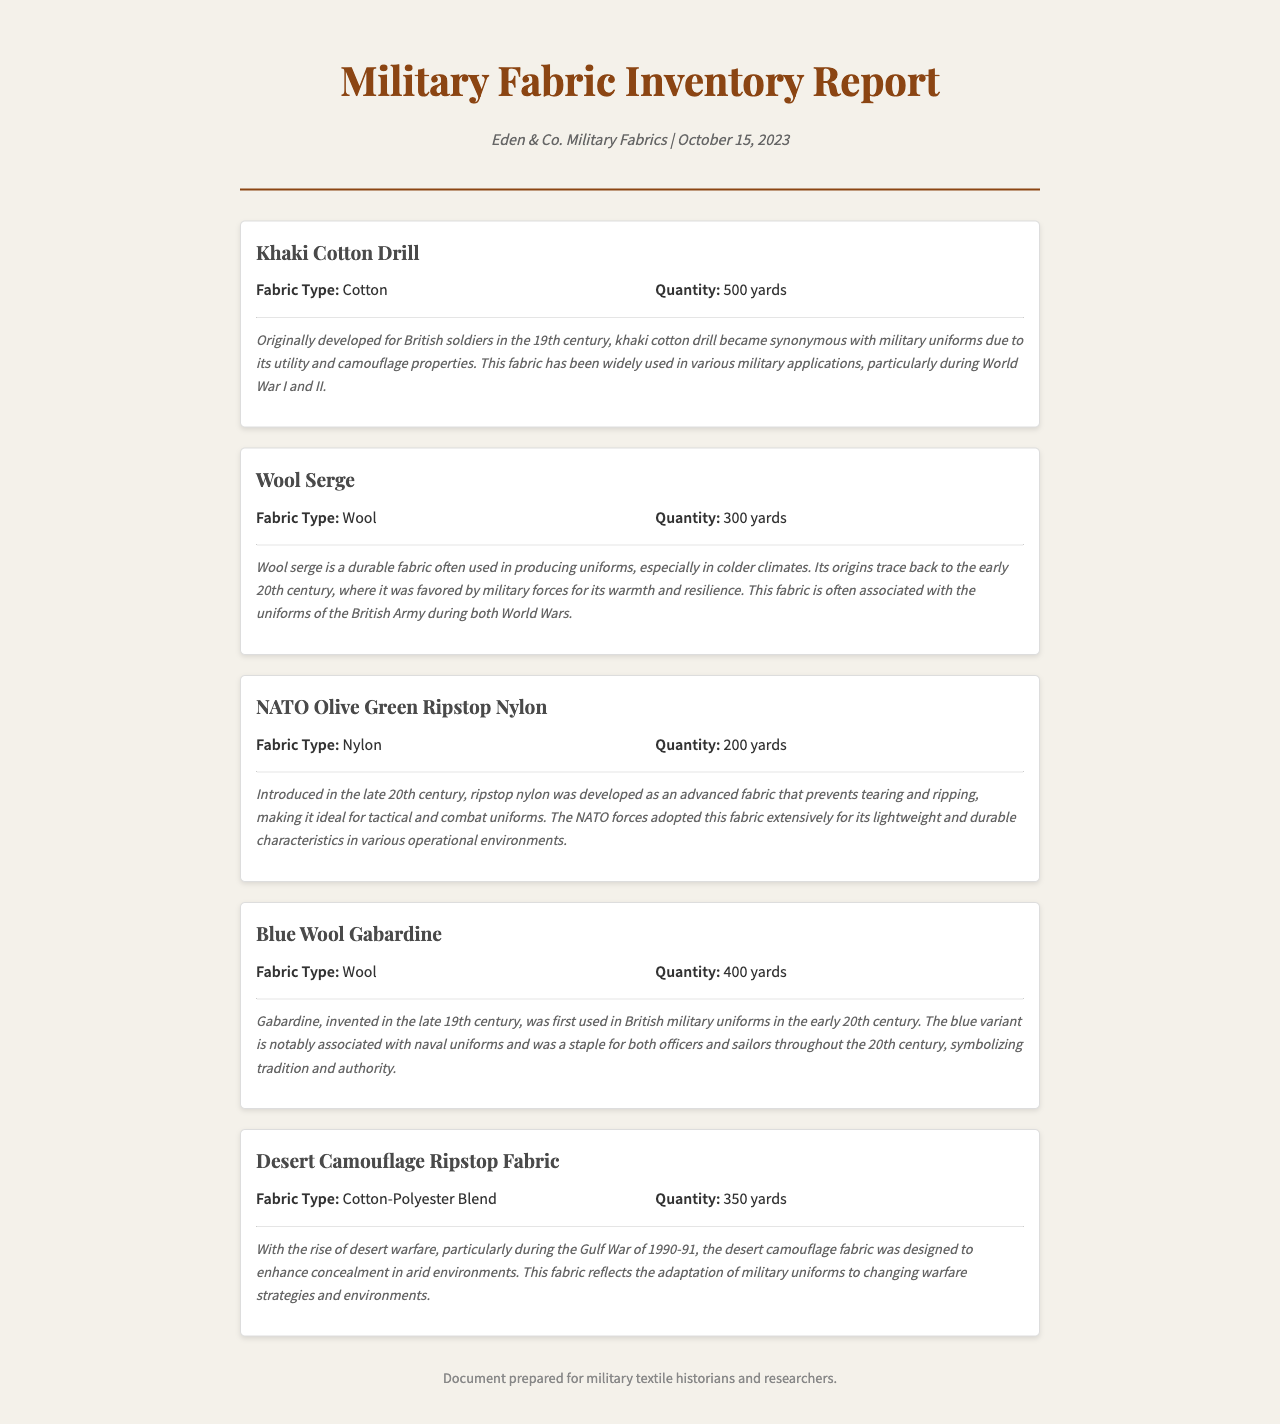What is the supplier's name? The supplier's name is mentioned at the top of the document as "Eden & Co. Military Fabrics."
Answer: Eden & Co. Military Fabrics How many yards of Khaki Cotton Drill are available? The quantity of Khaki Cotton Drill is specified in the inventory list as 500 yards.
Answer: 500 yards What type of fabric is Wool Serge? The document specifies the fabric type of Wool Serge as "Wool."
Answer: Wool What historical event is associated with Desert Camouflage Ripstop Fabric? The historical context mentions the Gulf War of 1990-91 in relation to the development of the fabric.
Answer: Gulf War of 1990-91 Which fabric type has the lowest quantity in the inventory? By comparing the quantities listed, it is evident that NATO Olive Green Ripstop Nylon has the lowest quantity of 200 yards.
Answer: 200 yards What is the primary purpose of using Khaki Cotton Drill? The historical context elaborates that it became synonymous with military uniforms due to its utility and camouflage properties.
Answer: Utility and camouflage What is the historical significance of Blue Wool Gabardine? The document notes that Blue Wool Gabardine is associated with naval uniforms and symbolizes tradition and authority.
Answer: Tradition and authority Which fabric is designed for colder climates? The historical context of Wool Serge indicates that it is favored for its warmth in colder climates.
Answer: Wool Serge What is the composition of Desert Camouflage Ripstop Fabric? The document specifies the fabric composition as a Cotton-Polyester Blend.
Answer: Cotton-Polyester Blend 